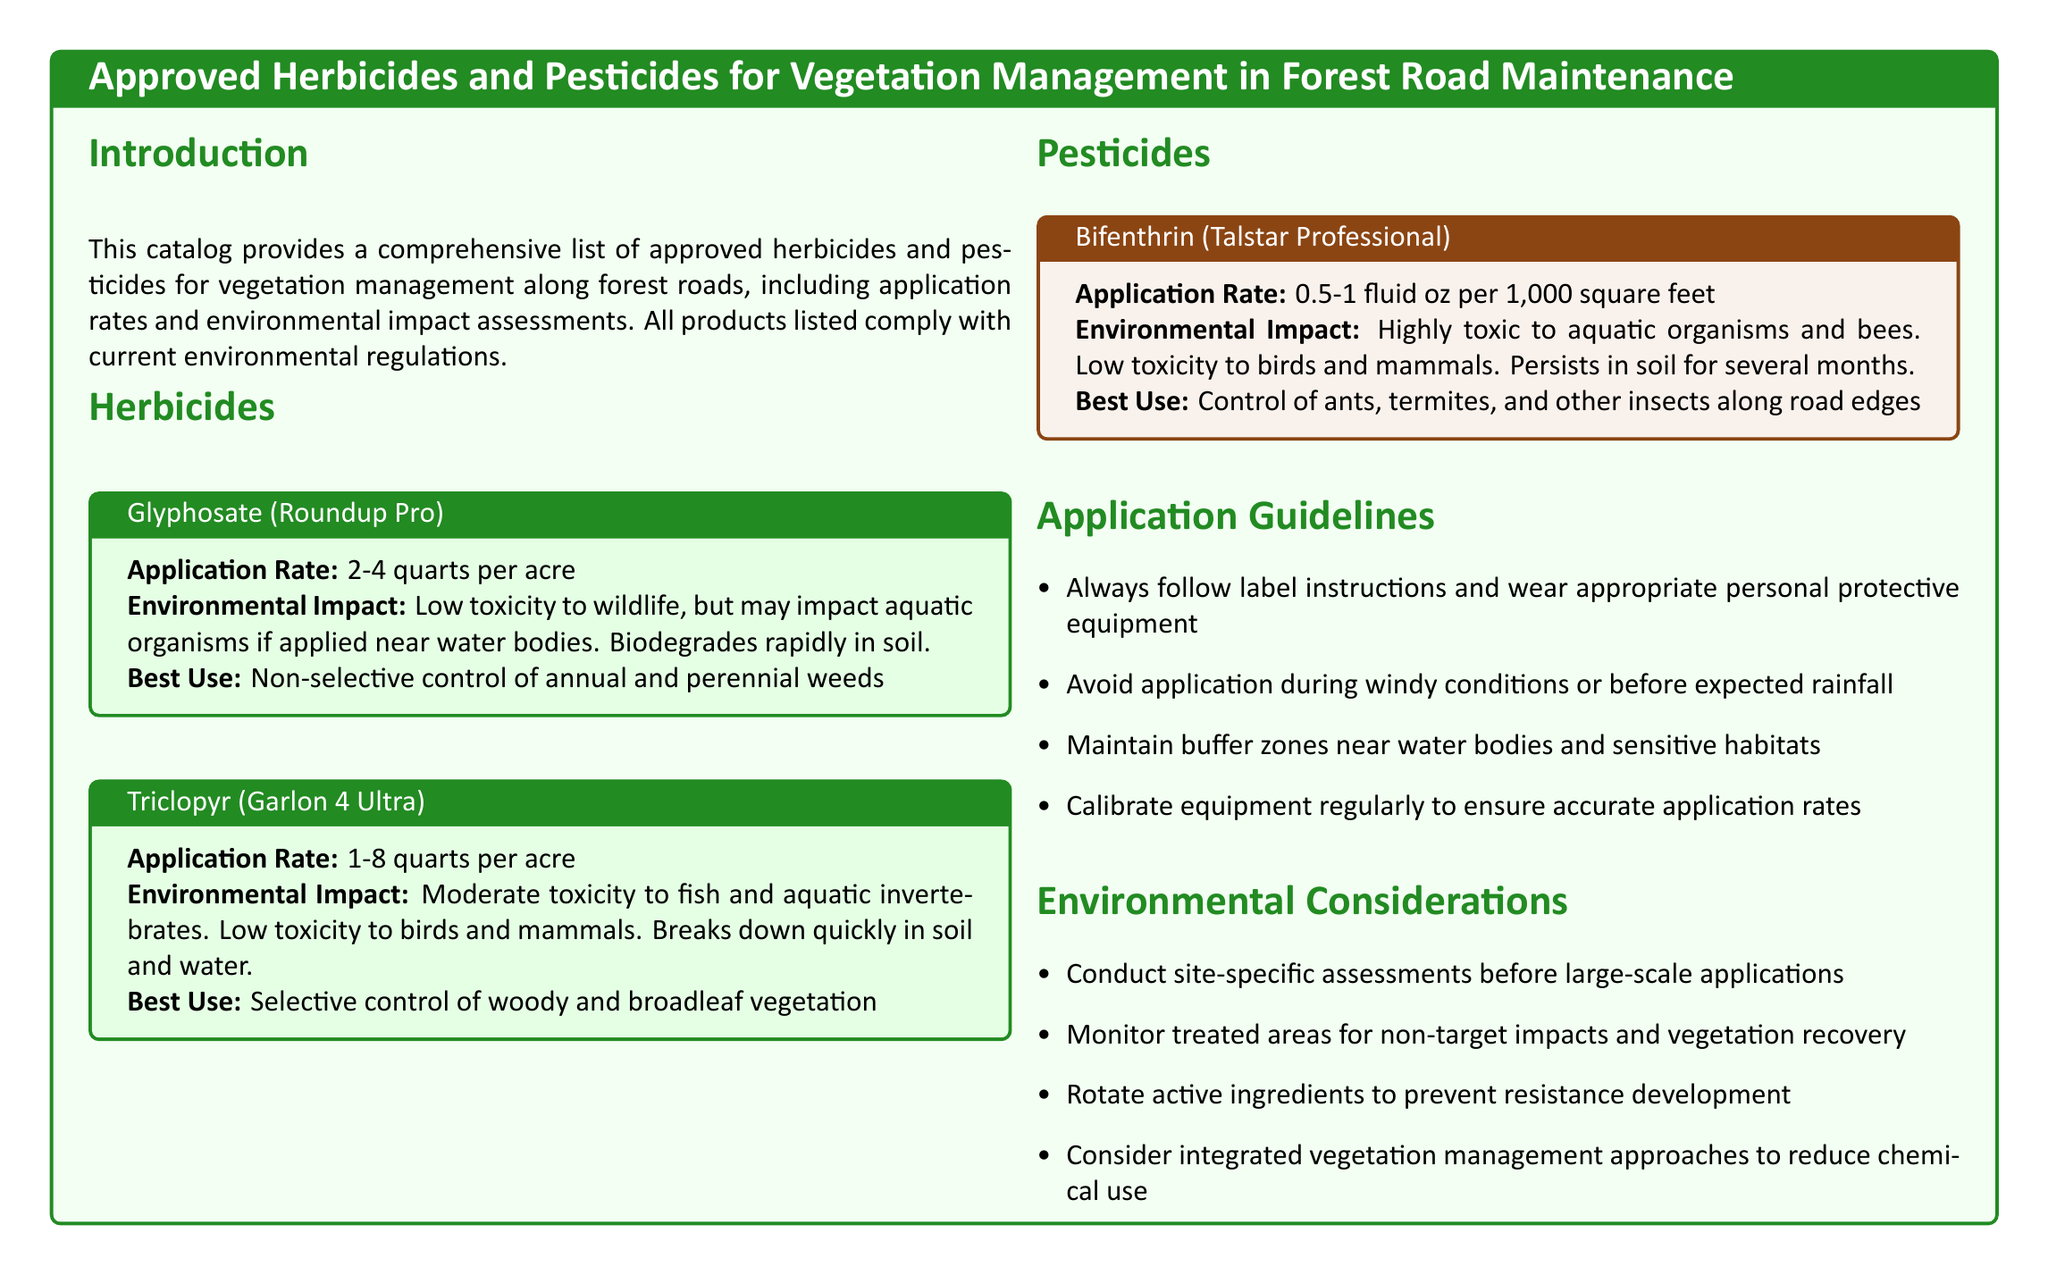What is the application rate for Glyphosate? The application rate for Glyphosate (Roundup Pro) is provided in the herbicides section of the document.
Answer: 2-4 quarts per acre What is the environmental impact of Triclopyr? The environmental impact of Triclopyr (Garlon 4 Ultra) is described in its specific section of the document, detailing its toxicity levels.
Answer: Moderate toxicity to fish and aquatic invertebrates What is the best use of Bifenthrin? The document lists the best use of Bifenthrin (Talstar Professional) in its pesticides section.
Answer: Control of ants, termites, and other insects along road edges What specific precautions should be taken during application? The application guidelines section contains key precautions to consider while applying herbicides and pesticides.
Answer: Maintain buffer zones near water bodies and sensitive habitats Which herbicide has low toxicity to wildlife? The document provides information about the toxicity levels of different herbicides listed in the catalog, including their effects on wildlife.
Answer: Glyphosate What should be monitored post-application? The environmental considerations section suggests monitoring certain aspects after herbicide and pesticide application.
Answer: Non-target impacts and vegetation recovery What is the application rate range for Triclopyr? This information can be found in the herbicides section of the document, specifically for Triclopyr.
Answer: 1-8 quarts per acre What is a potential impact of Glyphosate if applied near water bodies? The environmental impact assessment section describes the effects of Glyphosate when misapplied.
Answer: May impact aquatic organisms 